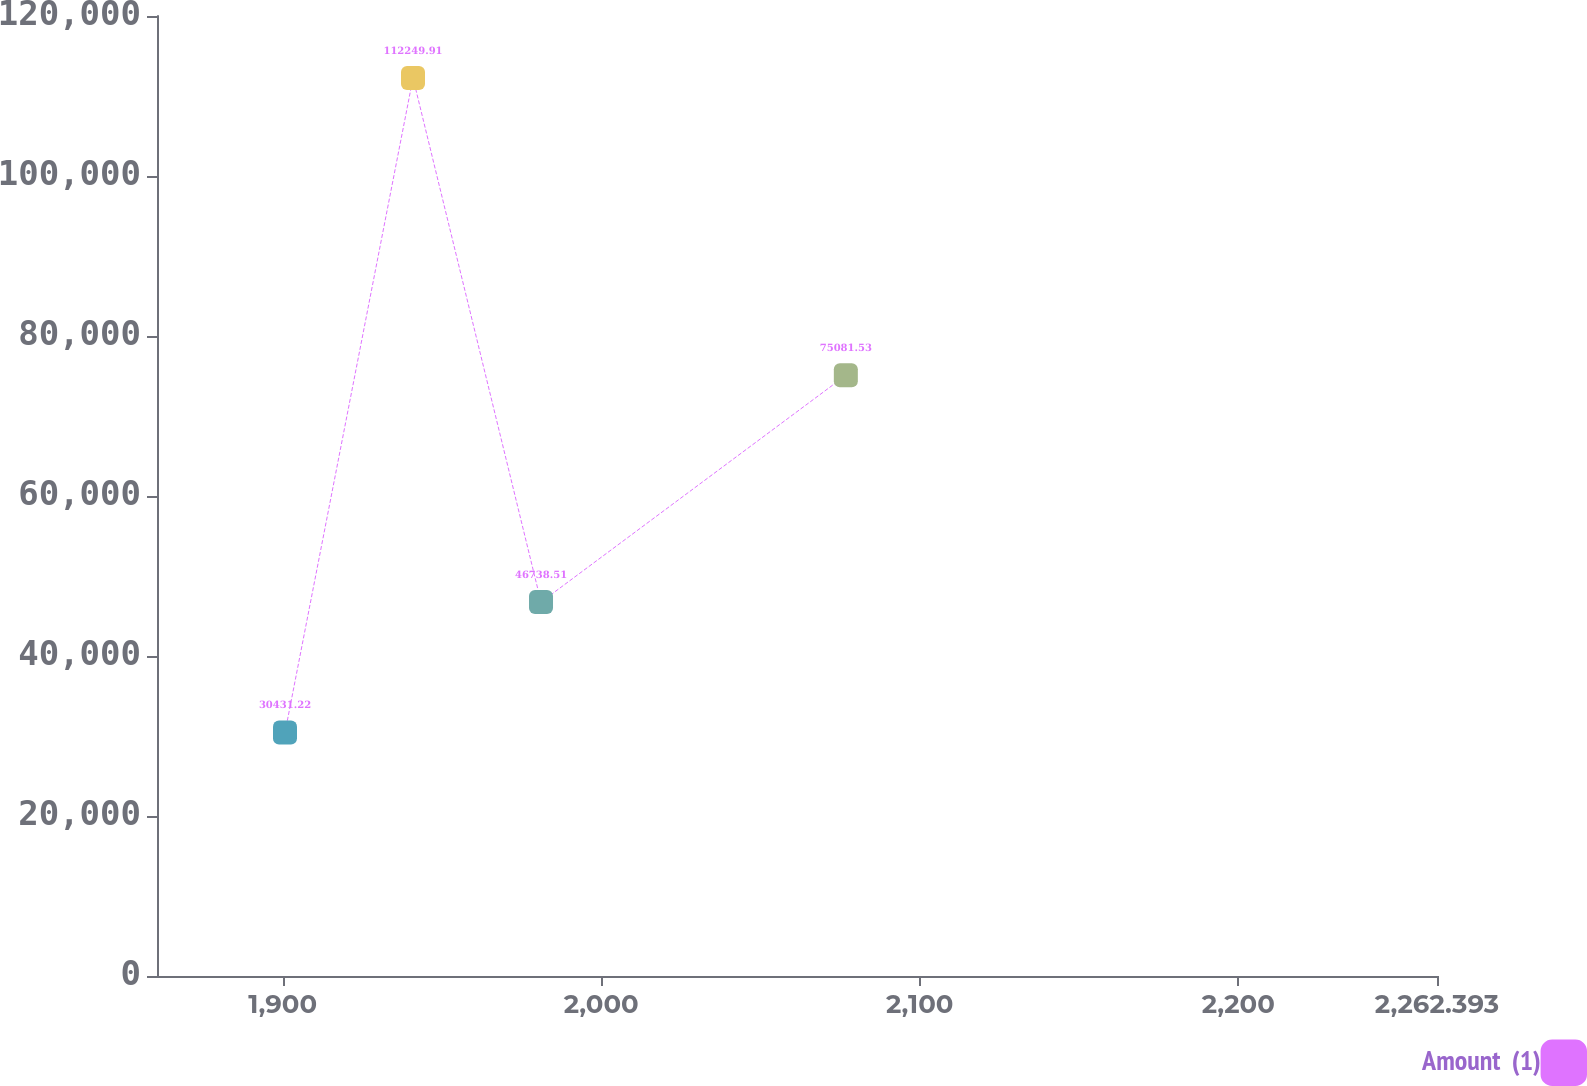Convert chart to OTSL. <chart><loc_0><loc_0><loc_500><loc_500><line_chart><ecel><fcel>Amount  (1)<nl><fcel>1900.71<fcel>30431.2<nl><fcel>1940.9<fcel>112250<nl><fcel>1981.09<fcel>46738.5<nl><fcel>2076.79<fcel>75081.5<nl><fcel>2302.58<fcel>193504<nl></chart> 